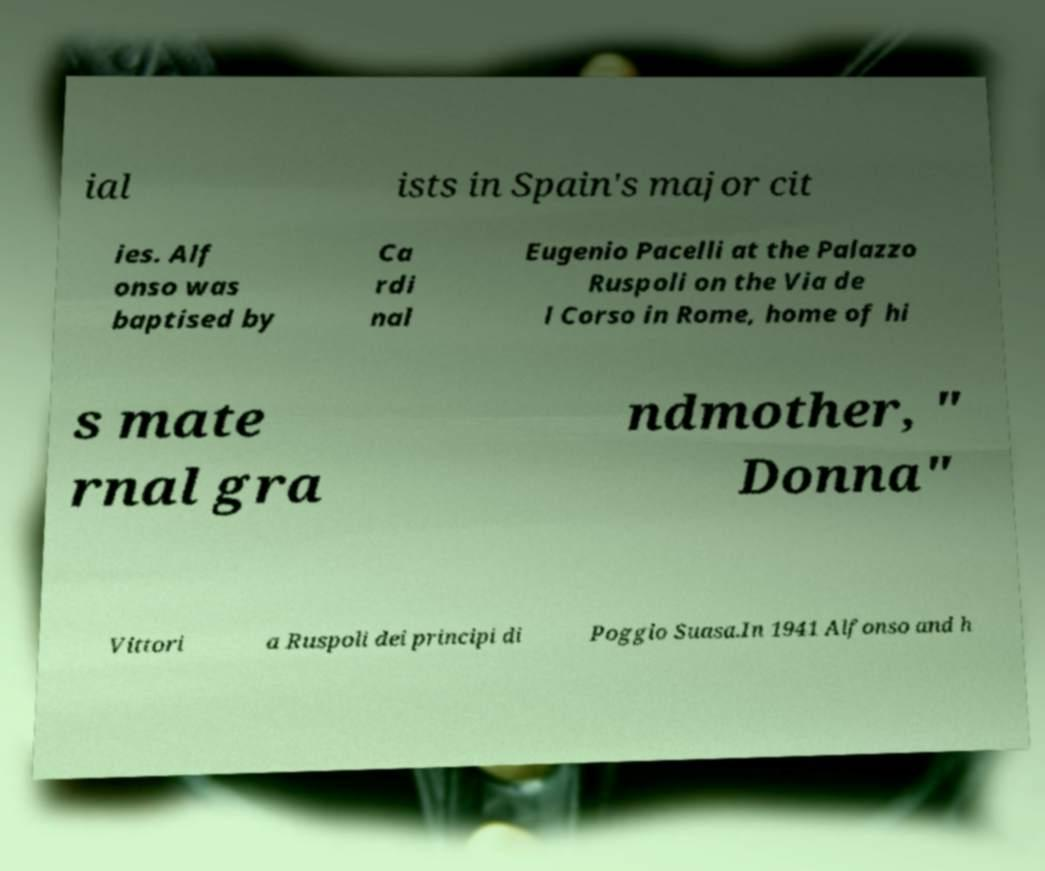Please read and relay the text visible in this image. What does it say? ial ists in Spain's major cit ies. Alf onso was baptised by Ca rdi nal Eugenio Pacelli at the Palazzo Ruspoli on the Via de l Corso in Rome, home of hi s mate rnal gra ndmother, " Donna" Vittori a Ruspoli dei principi di Poggio Suasa.In 1941 Alfonso and h 